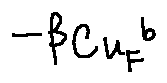Convert formula to latex. <formula><loc_0><loc_0><loc_500><loc_500>- \beta _ { C u _ { F } } b</formula> 